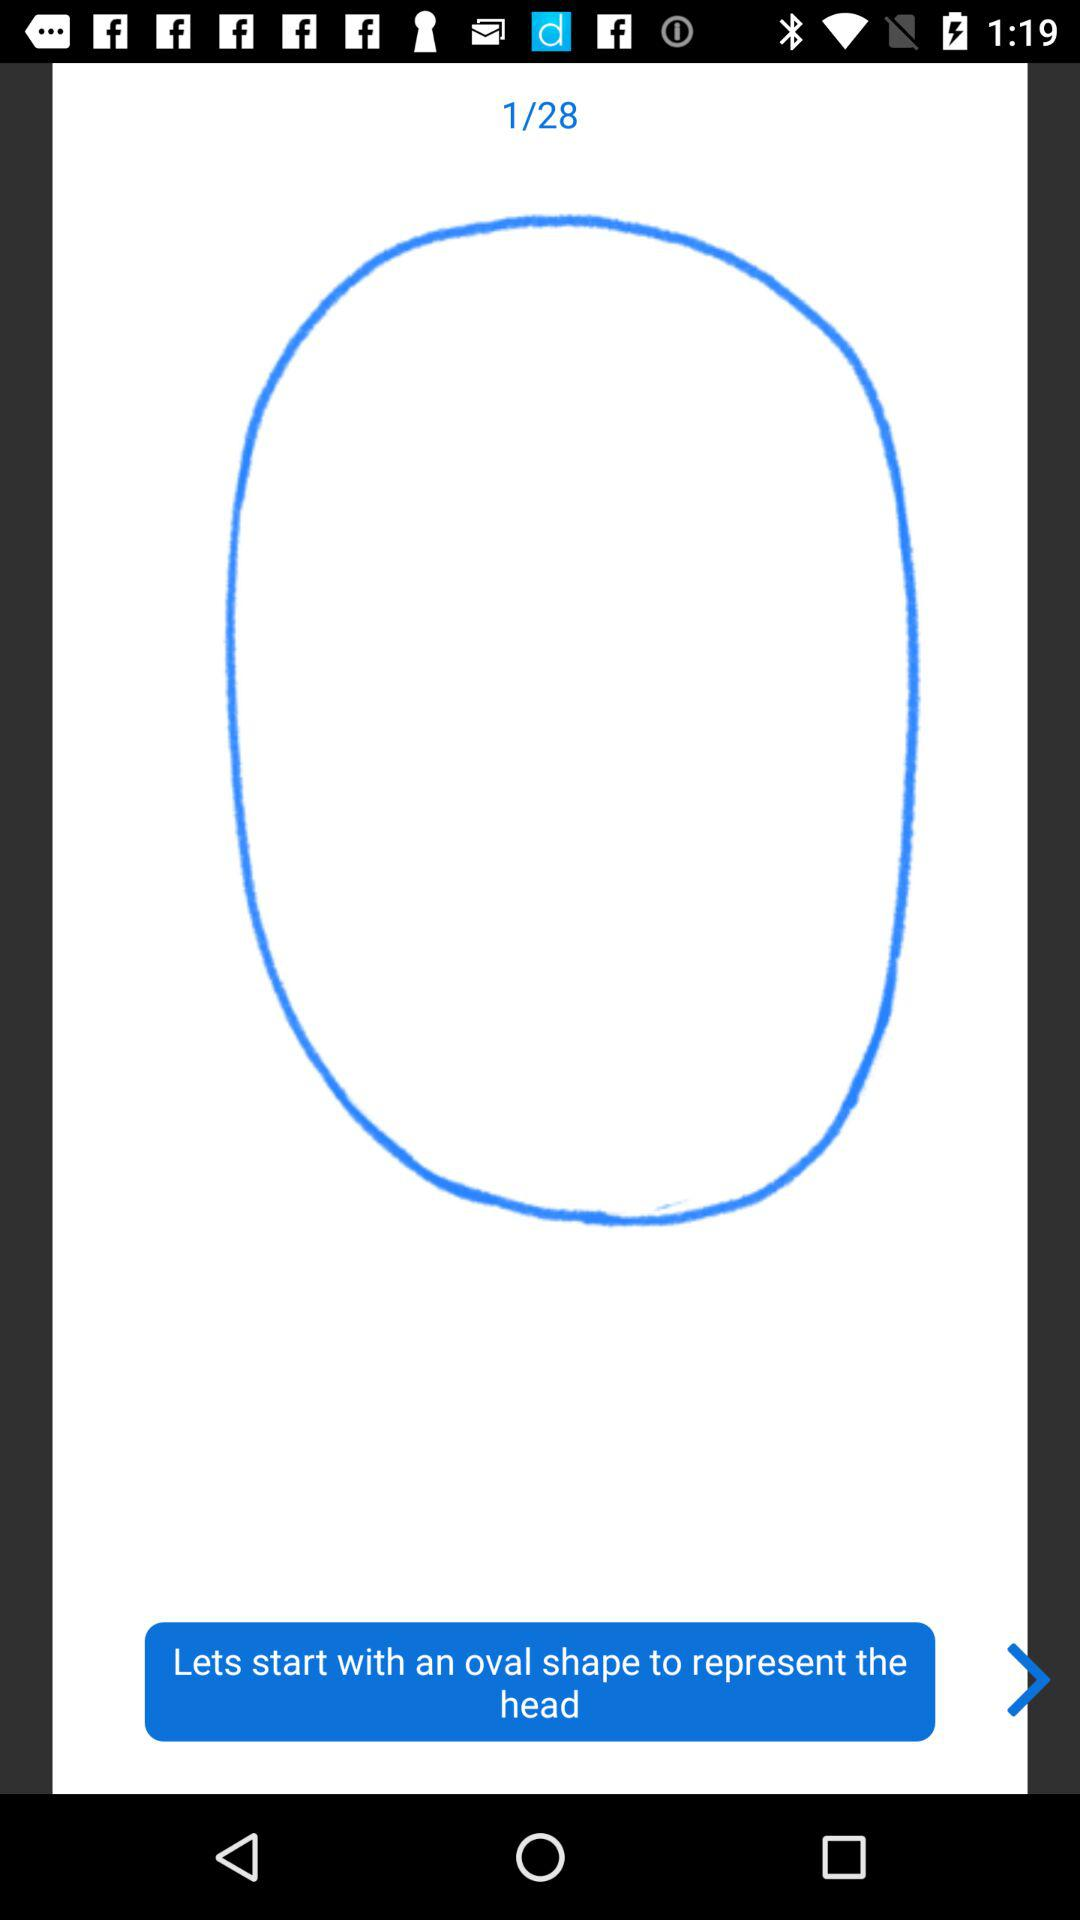What shape does the user need to start with to represent the head? The user needs to start with an oval shape to represent the head. 